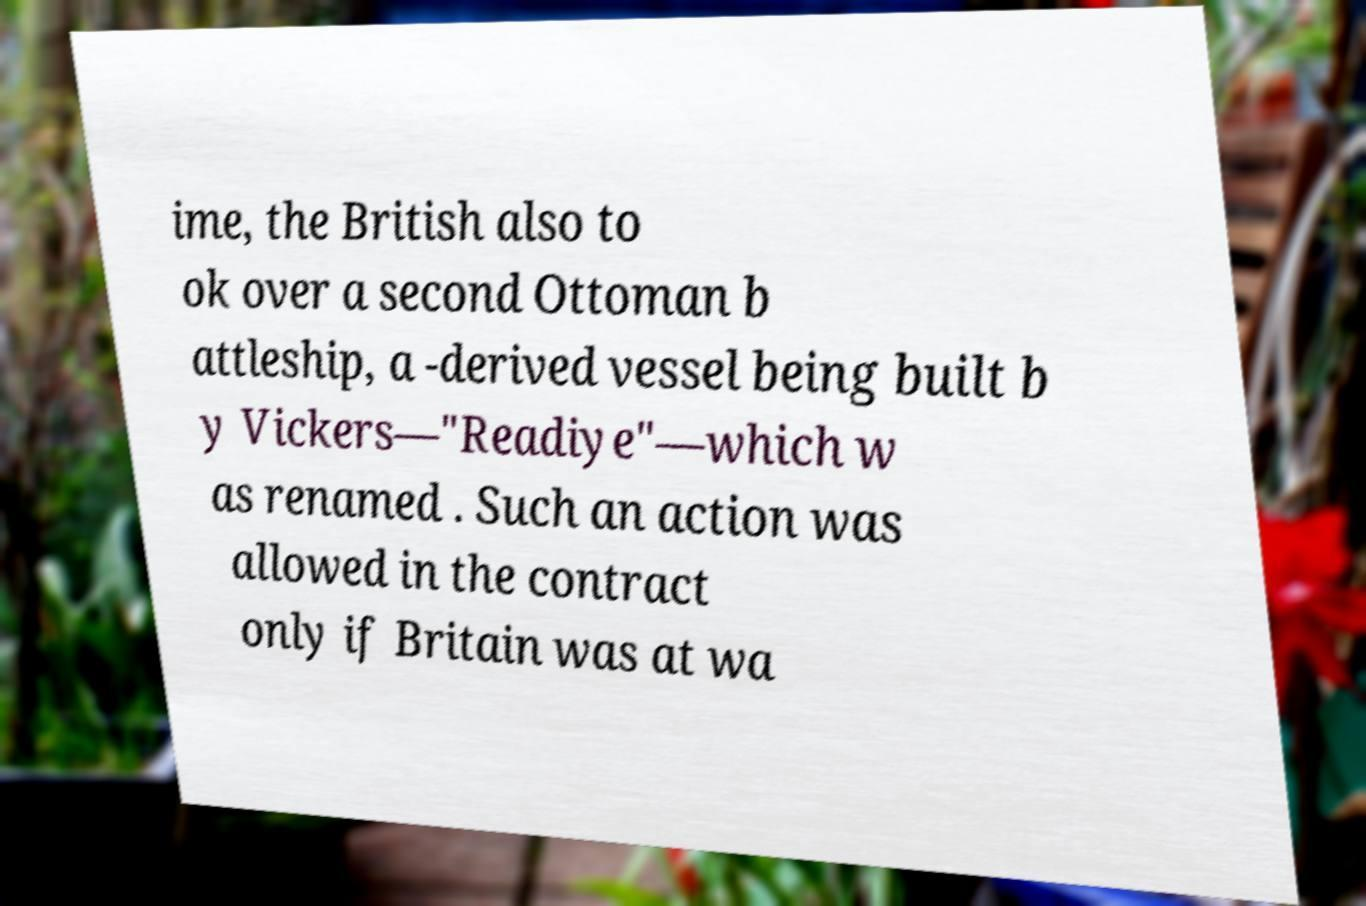I need the written content from this picture converted into text. Can you do that? ime, the British also to ok over a second Ottoman b attleship, a -derived vessel being built b y Vickers—"Readiye"—which w as renamed . Such an action was allowed in the contract only if Britain was at wa 